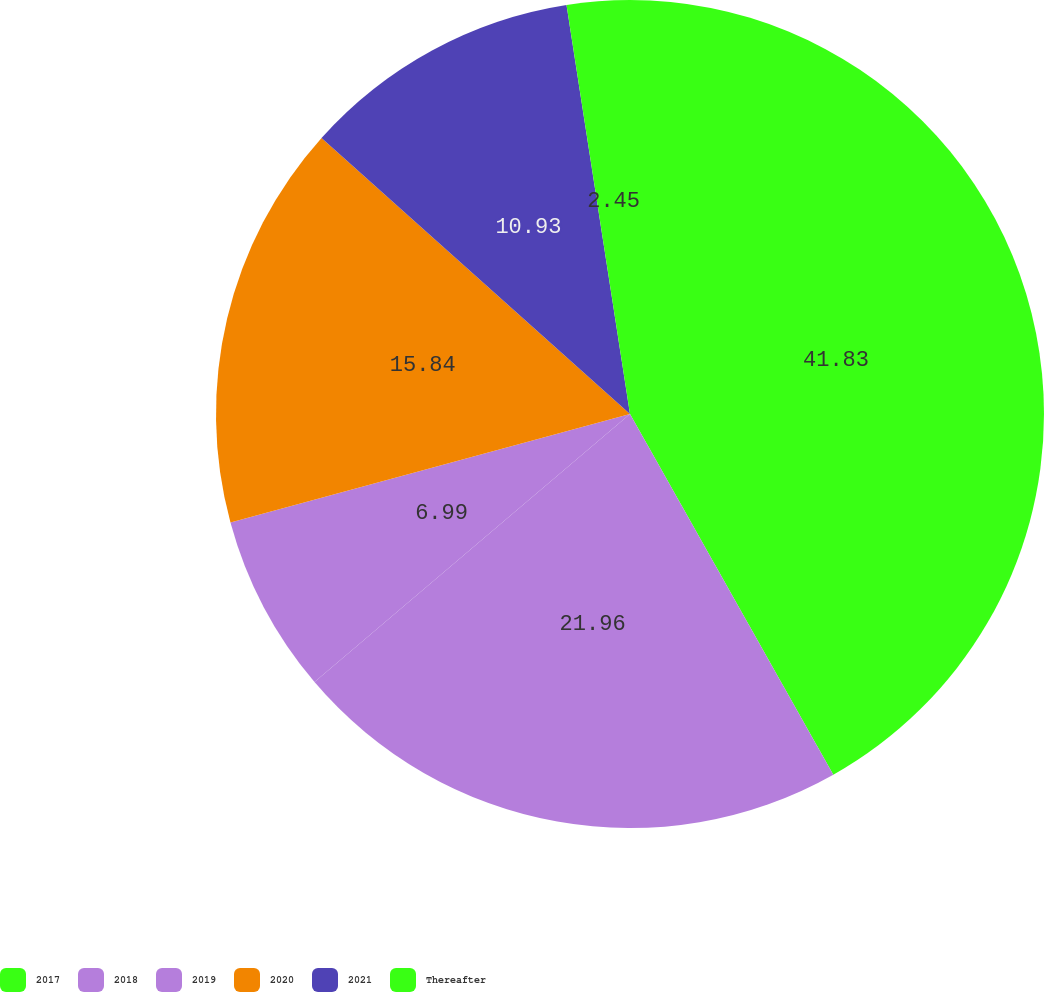<chart> <loc_0><loc_0><loc_500><loc_500><pie_chart><fcel>2017<fcel>2018<fcel>2019<fcel>2020<fcel>2021<fcel>Thereafter<nl><fcel>41.83%<fcel>21.96%<fcel>6.99%<fcel>15.84%<fcel>10.93%<fcel>2.45%<nl></chart> 